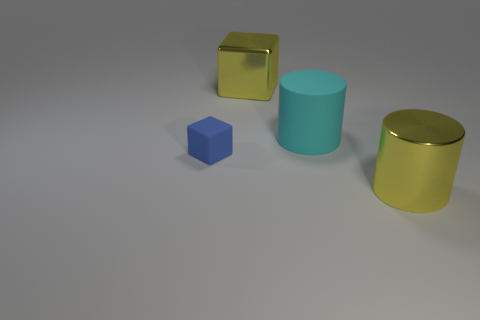What might be the function of these objects, considering their shapes and sizes? Given their simple geometric shapes and the context-free environment, these objects do not appear to have a specific function. They resemble basic three-dimensional shapes one might encounter in a visualization software or a virtual reality setting used for educational, design, or aesthetic purposes. 